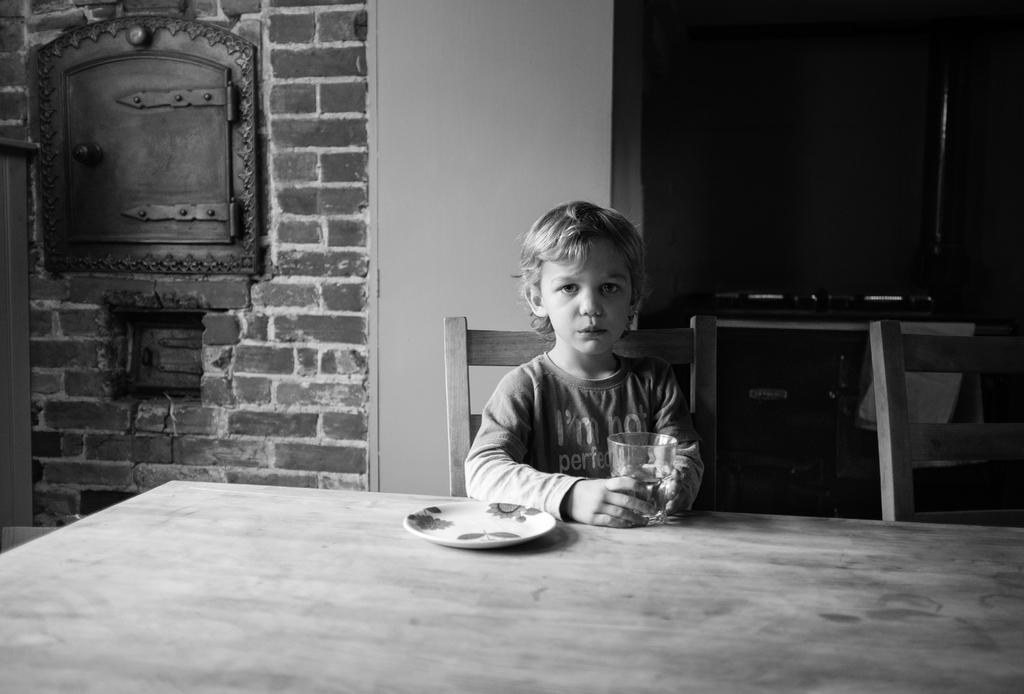What is the person in the image doing? The person is sitting on a chair. What is the person holding in the image? The person is holding a glass. What can be seen on the table in the image? There is a plate and a glass on the table. What is the color and texture of the wall in the background? The wall in the background is red and has a brick texture. What type of act is the person performing in the image? There is no act being performed in the image; the person is simply sitting on a chair. Is there a volcano visible in the image? No, there is no volcano present in the image. 